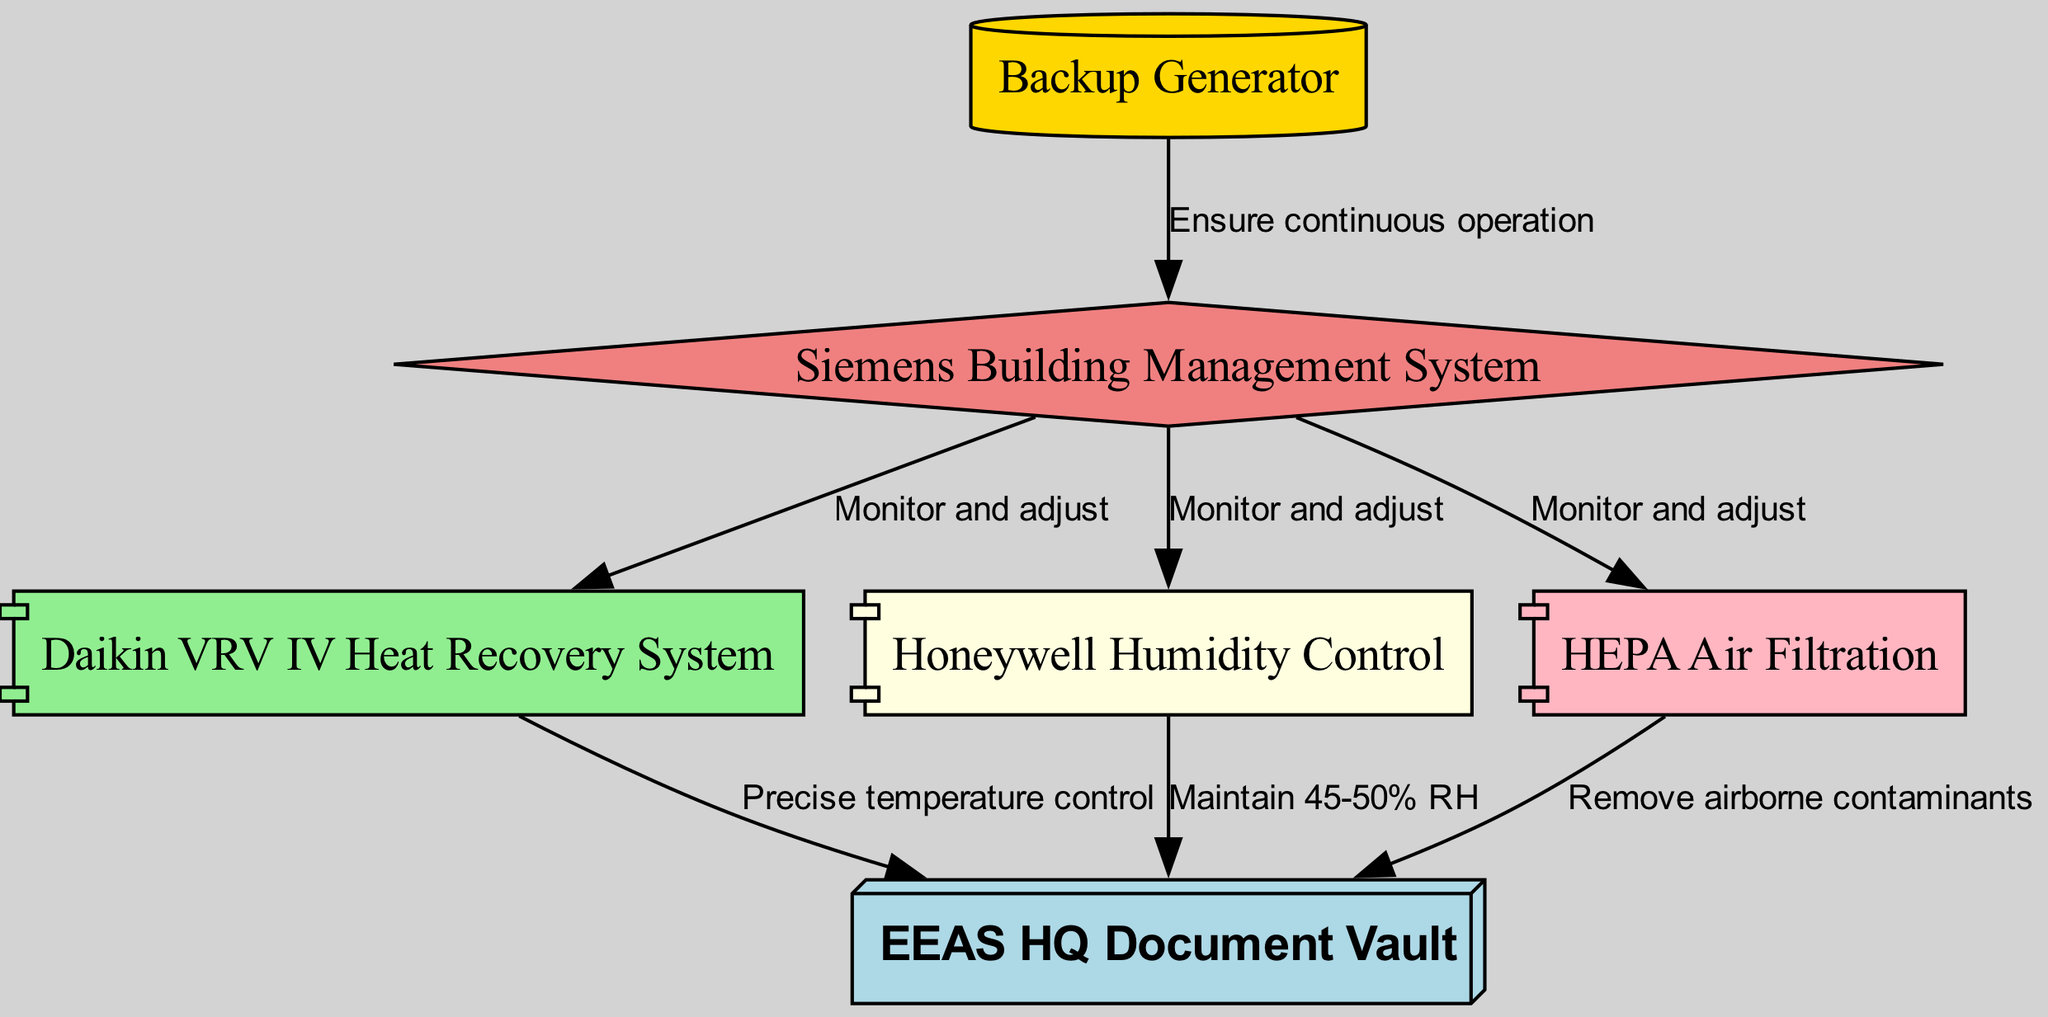What is the main document storage facility identified in the diagram? The diagram's central node, representing the primary facility, is labeled as "EEAS HQ Document Vault."
Answer: EEAS HQ Document Vault How many systems are directly linked to the EEAS HQ Document Vault? There are four systems connected to the "EEAS HQ Document Vault": the Daikin VRV IV heat recovery system, Honeywell humidity control, HEPA air filtration, and Siemens building management system.
Answer: Four What is the role of the Daikin VRV IV heat recovery system? It provides "Precise temperature control" to maintain suitable conditions for the sensitive documents stored in the vault, as indicated by the label on the edge connecting it to the vault.
Answer: Precise temperature control Which system monitors and adjusts the HEPA air filtration? The "Siemens Building Management System" is responsible for monitoring and adjusting the performance of the HEPA air filtration system, as shown by the directed edge between them.
Answer: Siemens Building Management System What ensures continuous operation of the Siemens Building Management System? The "Backup Generator" is linked to the Siemens Building Management System, ensuring its continuous operation according to the diagram's description of their relationship.
Answer: Backup Generator What percentage of relative humidity does the Honeywell humidity control maintain? The edge linking the Honeywell humidity control to the EEAS HQ Document Vault specifies it maintains a relative humidity of "45-50%."
Answer: 45-50% Which component is specifically used to remove airborne contaminants? The diagram explicitly states that the "HEPA Air Filtration" system is used for removing airborne contaminants, as indicated by the edge description connecting it to the document vault.
Answer: HEPA Air Filtration How does the Siemens Building Management System interact with the other systems? It monitors and adjusts the Daikin VRV IV heat recovery system, Honeywell humidity control, and HEPA air filtration, showing its pivotal role in overseeing the climate control system in the vault.
Answer: Monitor and adjust 